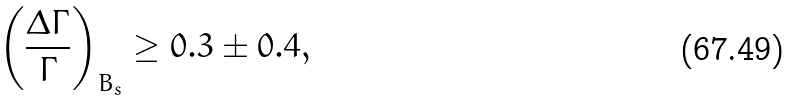<formula> <loc_0><loc_0><loc_500><loc_500>\left ( \frac { \Delta \Gamma } { \Gamma } \right ) _ { B _ { s } } \geq 0 . 3 \pm 0 . 4 ,</formula> 